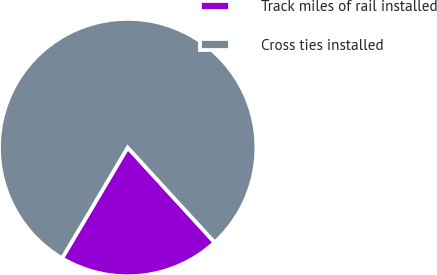<chart> <loc_0><loc_0><loc_500><loc_500><pie_chart><fcel>Track miles of rail installed<fcel>Cross ties installed<nl><fcel>20.32%<fcel>79.68%<nl></chart> 